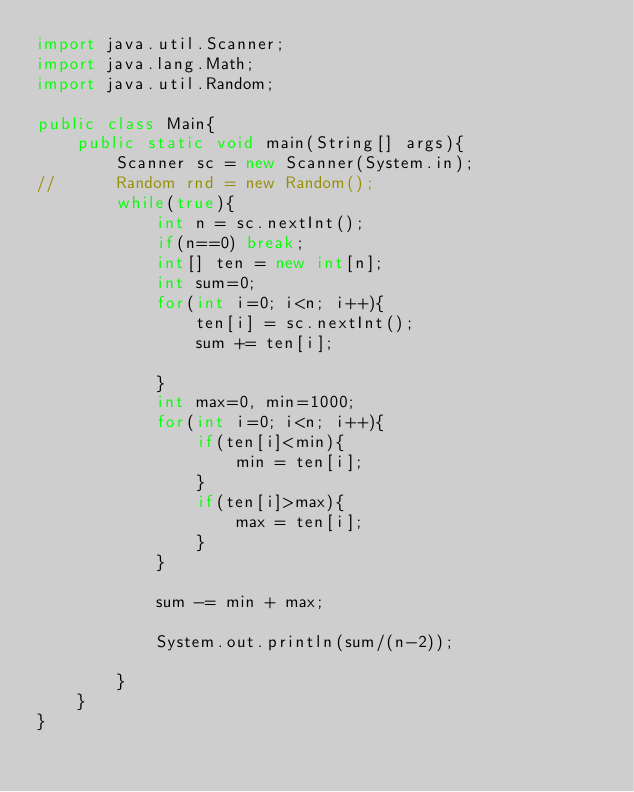Convert code to text. <code><loc_0><loc_0><loc_500><loc_500><_Java_>import java.util.Scanner;
import java.lang.Math;
import java.util.Random;

public class Main{
	public static void main(String[] args){
		Scanner sc = new Scanner(System.in);
//		Random rnd = new Random();
		while(true){
			int n = sc.nextInt();
			if(n==0) break;
			int[] ten = new int[n];
			int sum=0;
			for(int i=0; i<n; i++){
				ten[i] = sc.nextInt();
				sum += ten[i];

			}
			int max=0, min=1000;
			for(int i=0; i<n; i++){
				if(ten[i]<min){
					min = ten[i];
				}
				if(ten[i]>max){
					max = ten[i];
				}
			}			

			sum -= min + max;
			
			System.out.println(sum/(n-2));

		}
	}
}</code> 